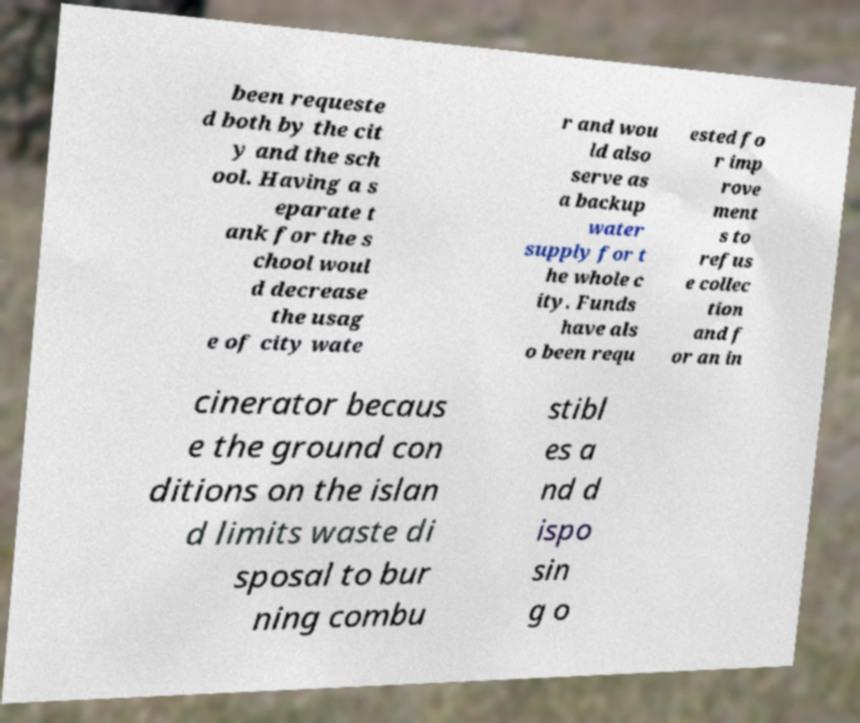Can you accurately transcribe the text from the provided image for me? been requeste d both by the cit y and the sch ool. Having a s eparate t ank for the s chool woul d decrease the usag e of city wate r and wou ld also serve as a backup water supply for t he whole c ity. Funds have als o been requ ested fo r imp rove ment s to refus e collec tion and f or an in cinerator becaus e the ground con ditions on the islan d limits waste di sposal to bur ning combu stibl es a nd d ispo sin g o 